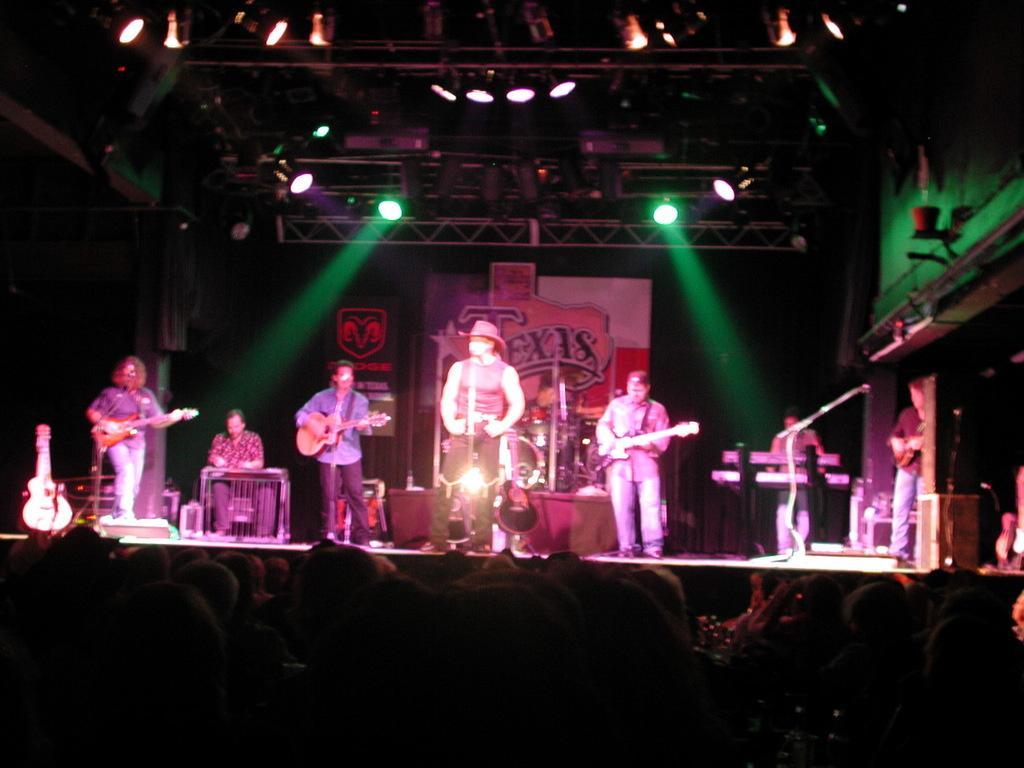Can you describe this image briefly? In this image, we can see people holding guitars and there are some other people, one of them is wearing a hat and there are some musical instruments. At the bottom, there is a crowd and in the background, there are boards and we can see lights and rods and some mic stands. 